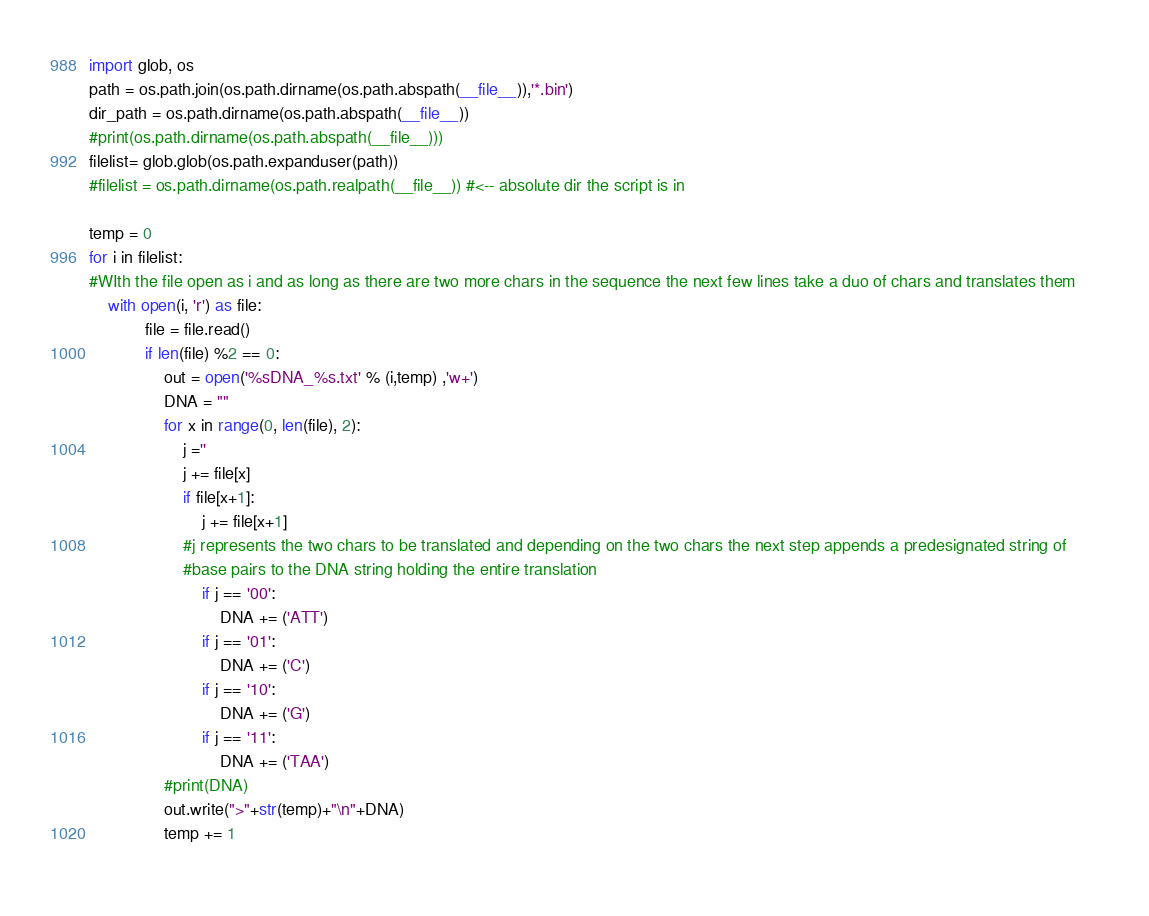<code> <loc_0><loc_0><loc_500><loc_500><_Python_>import glob, os
path = os.path.join(os.path.dirname(os.path.abspath(__file__)),'*.bin')
dir_path = os.path.dirname(os.path.abspath(__file__))
#print(os.path.dirname(os.path.abspath(__file__)))
filelist= glob.glob(os.path.expanduser(path))
#filelist = os.path.dirname(os.path.realpath(__file__)) #<-- absolute dir the script is in

temp = 0
for i in filelist:
#WIth the file open as i and as long as there are two more chars in the sequence the next few lines take a duo of chars and translates them     
    with open(i, 'r') as file:
            file = file.read()
            if len(file) %2 == 0:
                out = open('%sDNA_%s.txt' % (i,temp) ,'w+')
                DNA = ""
                for x in range(0, len(file), 2):
                    j =''    
                    j += file[x]
                    if file[x+1]:
                        j += file[x+1]
                    #j represents the two chars to be translated and depending on the two chars the next step appends a predesignated string of 
                    #base pairs to the DNA string holding the entire translation 
                        if j == '00':
                            DNA += ('ATT')
                        if j == '01':        
                            DNA += ('C')
                        if j == '10':
                            DNA += ('G')
                        if j == '11':        
                            DNA += ('TAA')
                #print(DNA)
                out.write(">"+str(temp)+"\n"+DNA)
                temp += 1
            
</code> 